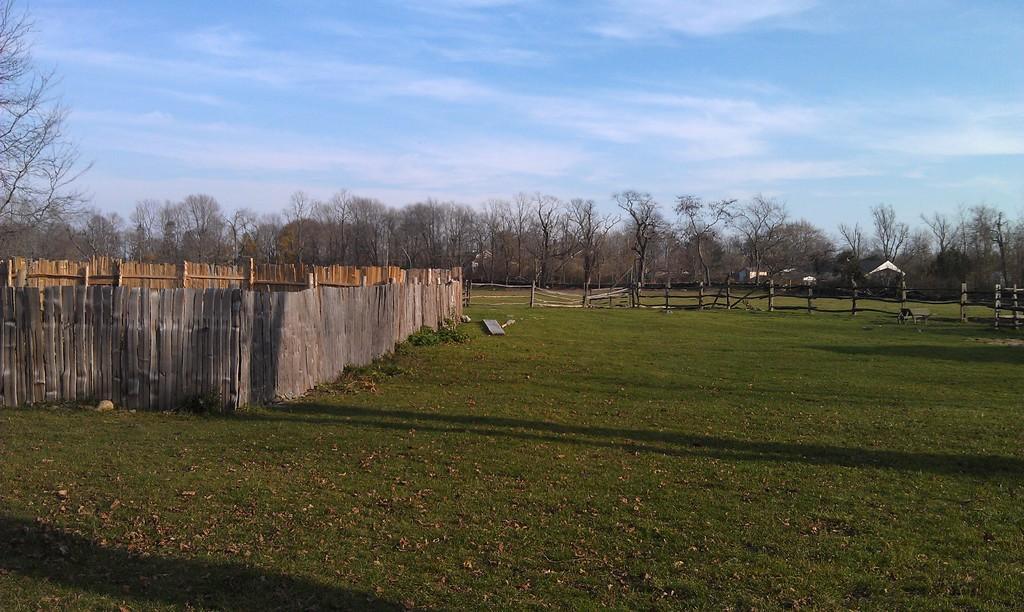How would you summarize this image in a sentence or two? In this image we can see the grass and dried leaves. We can see the wooden fencing and the trees. And at the top we can see the sky. 